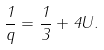<formula> <loc_0><loc_0><loc_500><loc_500>\frac { 1 } { q } = \frac { 1 } { 3 } + 4 U .</formula> 